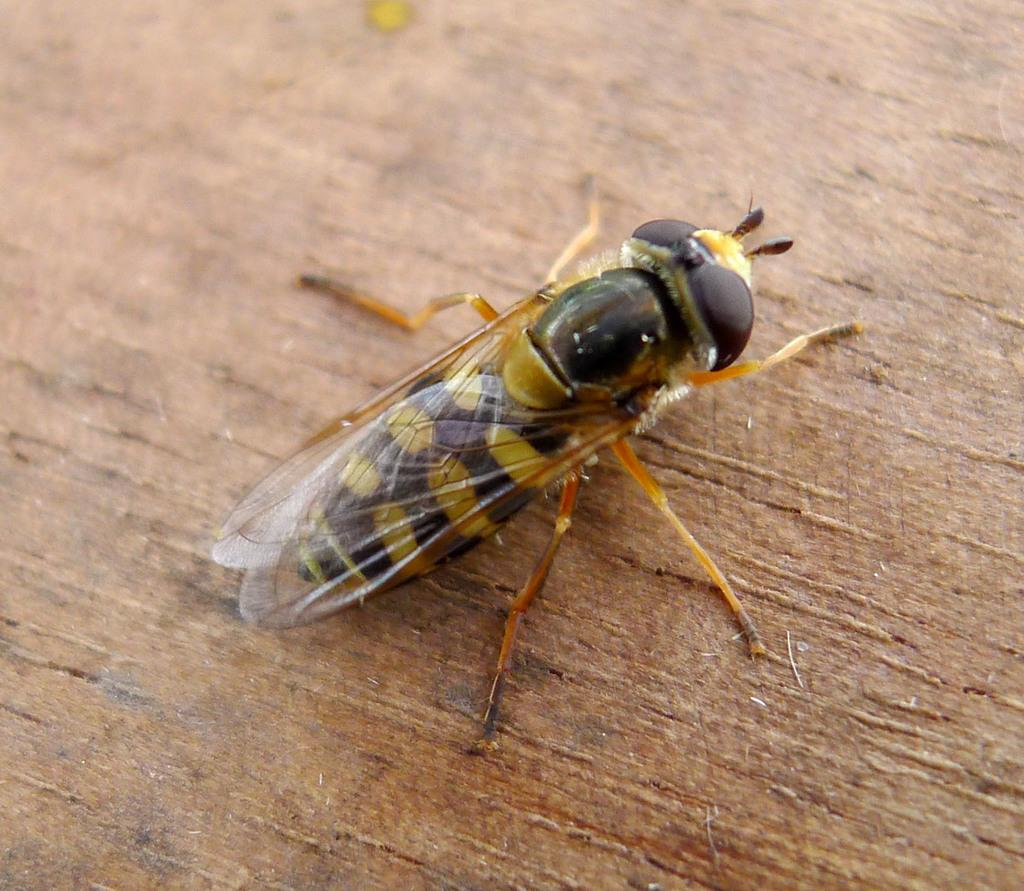What type of insect is in the image? There is a honey bee in the image. What colors can be seen on the honey bee? The honey bee is in black and yellow color. What is the honey bee standing on in the image? The honey bee is on a brown surface. Can you see a snake slithering on the brown surface in the image? No, there is no snake present in the image; it only features a honey bee. 